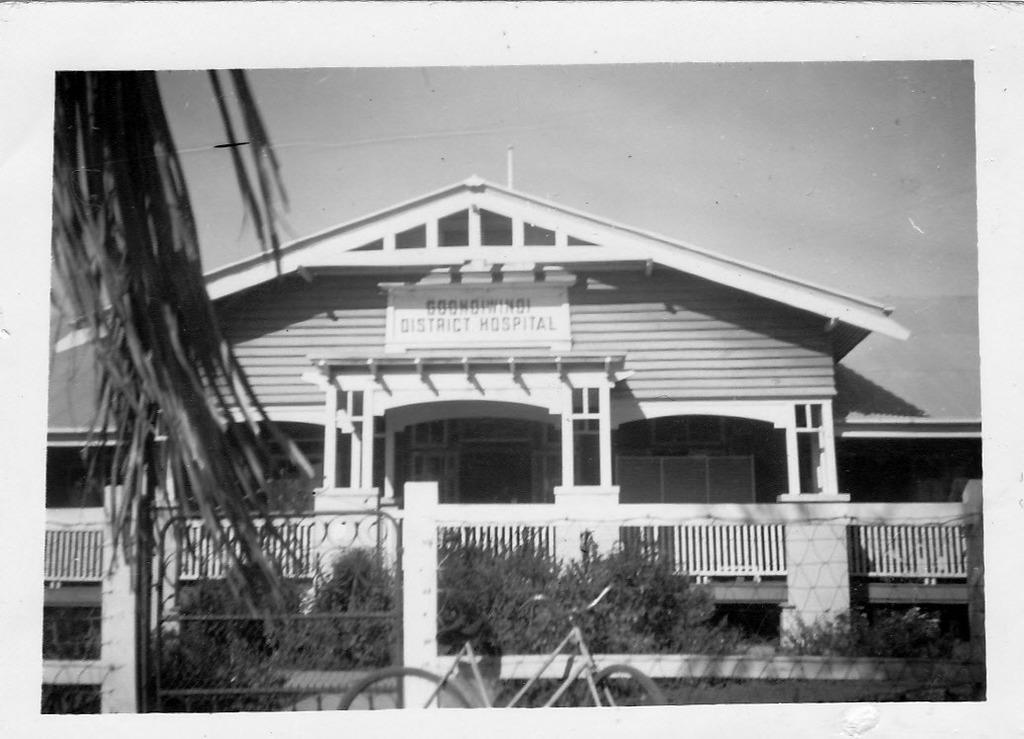Please provide a concise description of this image. This is a black and white image. In this image we can see a building with pillars and name board. Also there are railings. In front of the building there are plants. Also there is a cycle. 